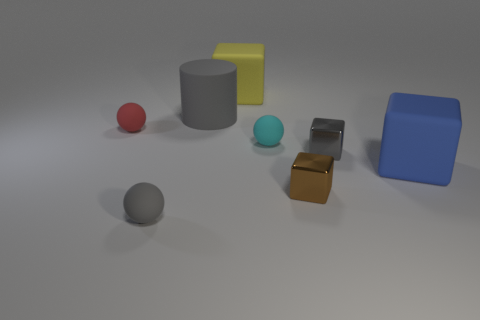There is a small cube that is the same color as the matte cylinder; what is it made of?
Provide a succinct answer. Metal. What number of other things are there of the same color as the big matte cylinder?
Provide a short and direct response. 2. There is a cube that is both behind the big blue object and to the left of the small gray cube; how big is it?
Give a very brief answer. Large. There is a yellow thing that is the same shape as the blue thing; what material is it?
Make the answer very short. Rubber. Does the tiny shiny thing behind the big blue block have the same color as the small ball in front of the blue rubber cube?
Provide a succinct answer. Yes. What is the shape of the tiny gray thing that is in front of the tiny brown cube?
Offer a very short reply. Sphere. The large cylinder is what color?
Make the answer very short. Gray. There is a big gray object that is made of the same material as the tiny cyan object; what shape is it?
Make the answer very short. Cylinder. There is a gray thing that is left of the cylinder; does it have the same size as the gray cylinder?
Give a very brief answer. No. What number of things are big cubes that are on the left side of the small brown object or small things on the left side of the large gray cylinder?
Make the answer very short. 3. 